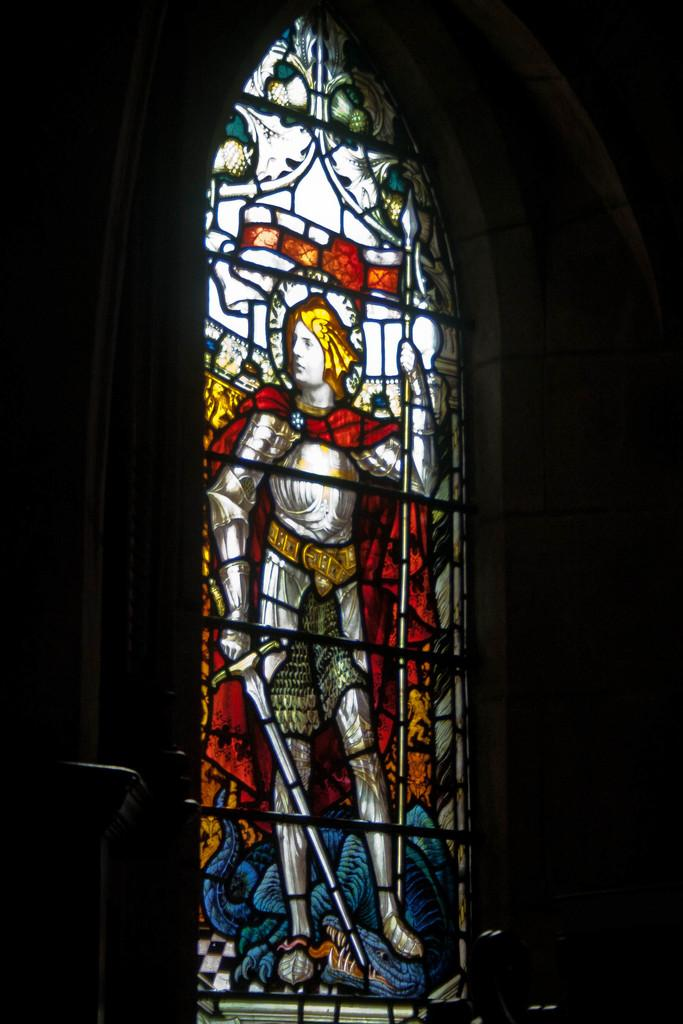What is present in the image that serves as a barrier or divider? There is a wall in the image. What object can be seen in the image that is typically used for holding liquids? There is a glass in the image. What is depicted on the glass? The glass has an image of a person holding objects. How many bats are hanging from the wall in the image? There are no bats present in the image; it features a wall and a glass with an image of a person holding objects. What type of representative can be seen in the image? There is no representative present in the image; it only features a wall, a glass, and an image of a person holding objects. 